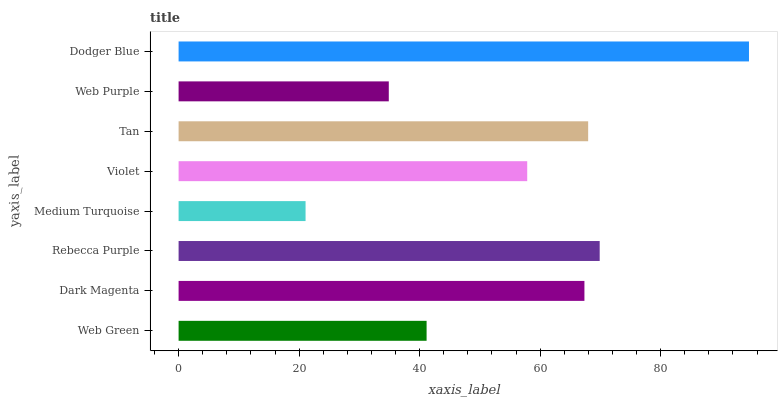Is Medium Turquoise the minimum?
Answer yes or no. Yes. Is Dodger Blue the maximum?
Answer yes or no. Yes. Is Dark Magenta the minimum?
Answer yes or no. No. Is Dark Magenta the maximum?
Answer yes or no. No. Is Dark Magenta greater than Web Green?
Answer yes or no. Yes. Is Web Green less than Dark Magenta?
Answer yes or no. Yes. Is Web Green greater than Dark Magenta?
Answer yes or no. No. Is Dark Magenta less than Web Green?
Answer yes or no. No. Is Dark Magenta the high median?
Answer yes or no. Yes. Is Violet the low median?
Answer yes or no. Yes. Is Tan the high median?
Answer yes or no. No. Is Rebecca Purple the low median?
Answer yes or no. No. 